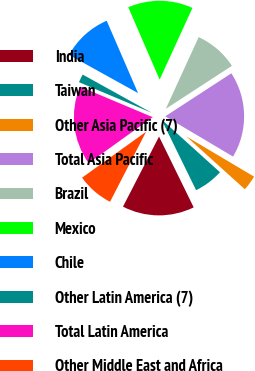Convert chart. <chart><loc_0><loc_0><loc_500><loc_500><pie_chart><fcel>India<fcel>Taiwan<fcel>Other Asia Pacific (7)<fcel>Total Asia Pacific<fcel>Brazil<fcel>Mexico<fcel>Chile<fcel>Other Latin America (7)<fcel>Total Latin America<fcel>Other Middle East and Africa<nl><fcel>14.8%<fcel>6.07%<fcel>3.16%<fcel>17.71%<fcel>8.98%<fcel>13.34%<fcel>10.44%<fcel>1.71%<fcel>16.25%<fcel>7.53%<nl></chart> 